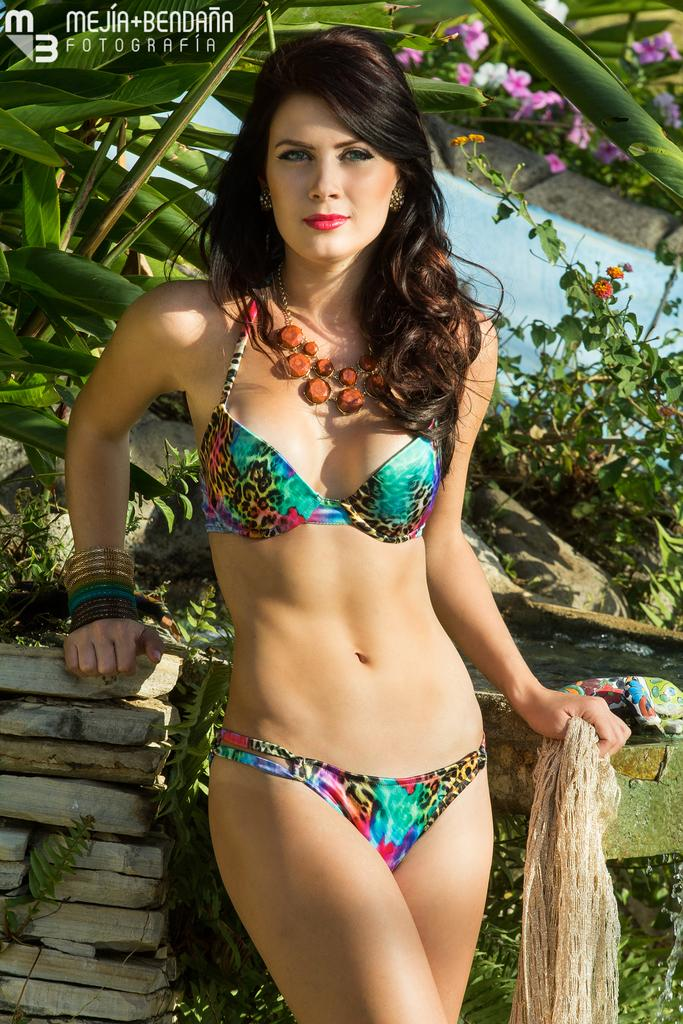Who is the main subject in the image? There is a woman in the image. What is the woman doing in the image? The woman is standing. What type of vegetation is visible behind the woman? There are plants behind the woman. What additional floral elements can be seen in the image? There are flowers visible at the top of the image. What type of toad can be seen exchanging positions with the woman in the image? There is no toad present in the image, and the woman is not exchanging positions with any other subject. 